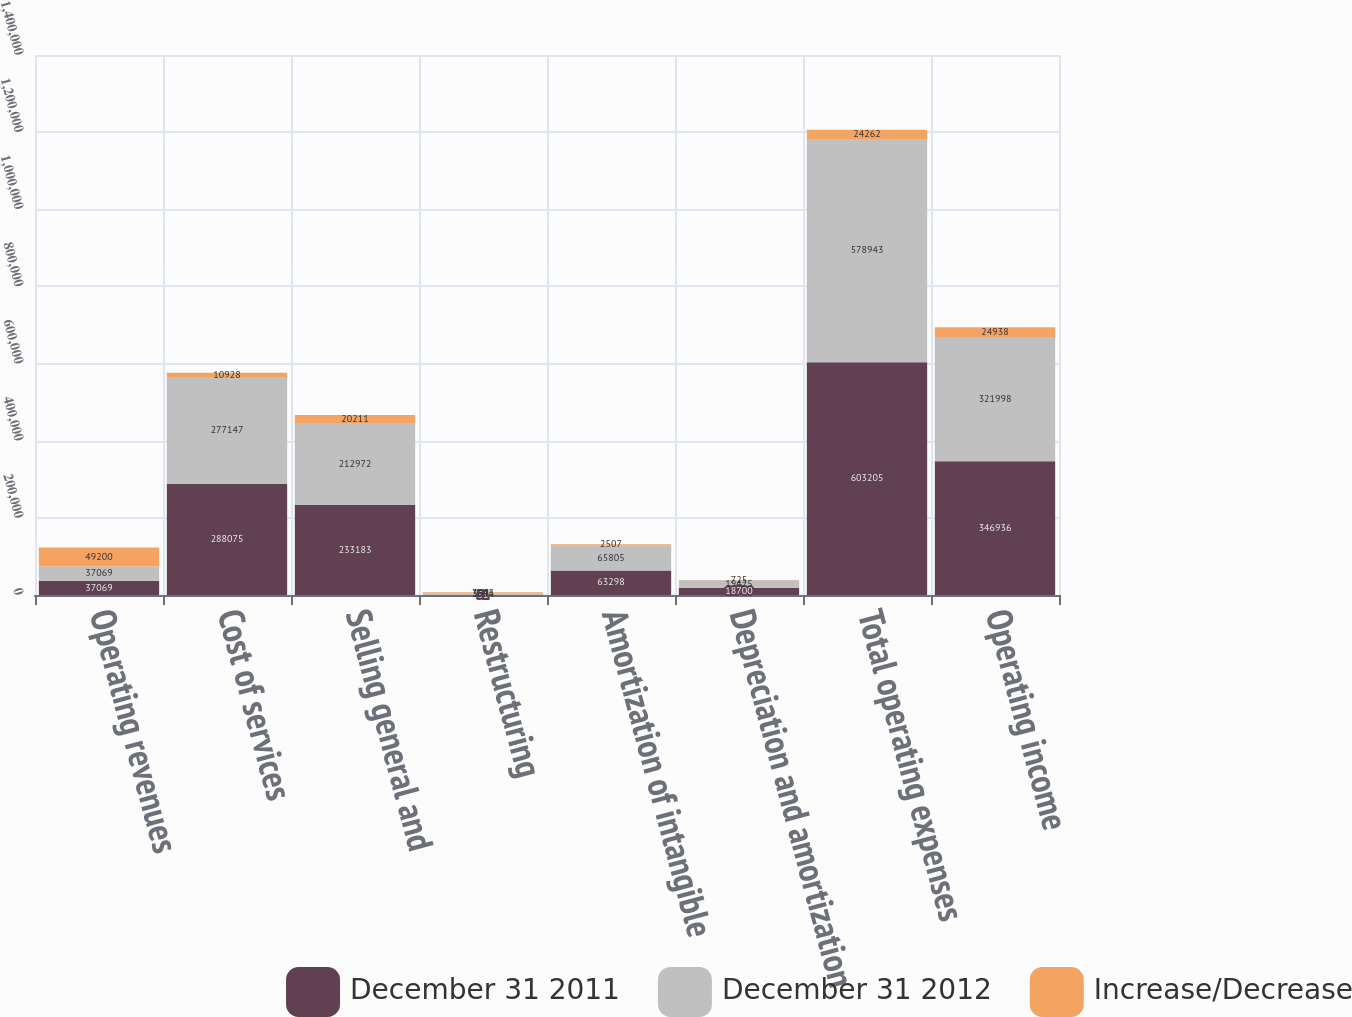Convert chart. <chart><loc_0><loc_0><loc_500><loc_500><stacked_bar_chart><ecel><fcel>Operating revenues<fcel>Cost of services<fcel>Selling general and<fcel>Restructuring<fcel>Amortization of intangible<fcel>Depreciation and amortization<fcel>Total operating expenses<fcel>Operating income<nl><fcel>December 31 2011<fcel>37069<fcel>288075<fcel>233183<fcel>51<fcel>63298<fcel>18700<fcel>603205<fcel>346936<nl><fcel>December 31 2012<fcel>37069<fcel>277147<fcel>212972<fcel>3594<fcel>65805<fcel>19425<fcel>578943<fcel>321998<nl><fcel>Increase/Decrease<fcel>49200<fcel>10928<fcel>20211<fcel>3645<fcel>2507<fcel>725<fcel>24262<fcel>24938<nl></chart> 